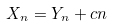Convert formula to latex. <formula><loc_0><loc_0><loc_500><loc_500>X _ { n } = Y _ { n } + c n</formula> 